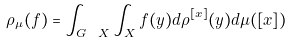Convert formula to latex. <formula><loc_0><loc_0><loc_500><loc_500>\rho _ { \mu } ( f ) = \int _ { G \ X } \int _ { X } f ( y ) d \rho ^ { [ x ] } ( y ) d \mu ( [ x ] )</formula> 